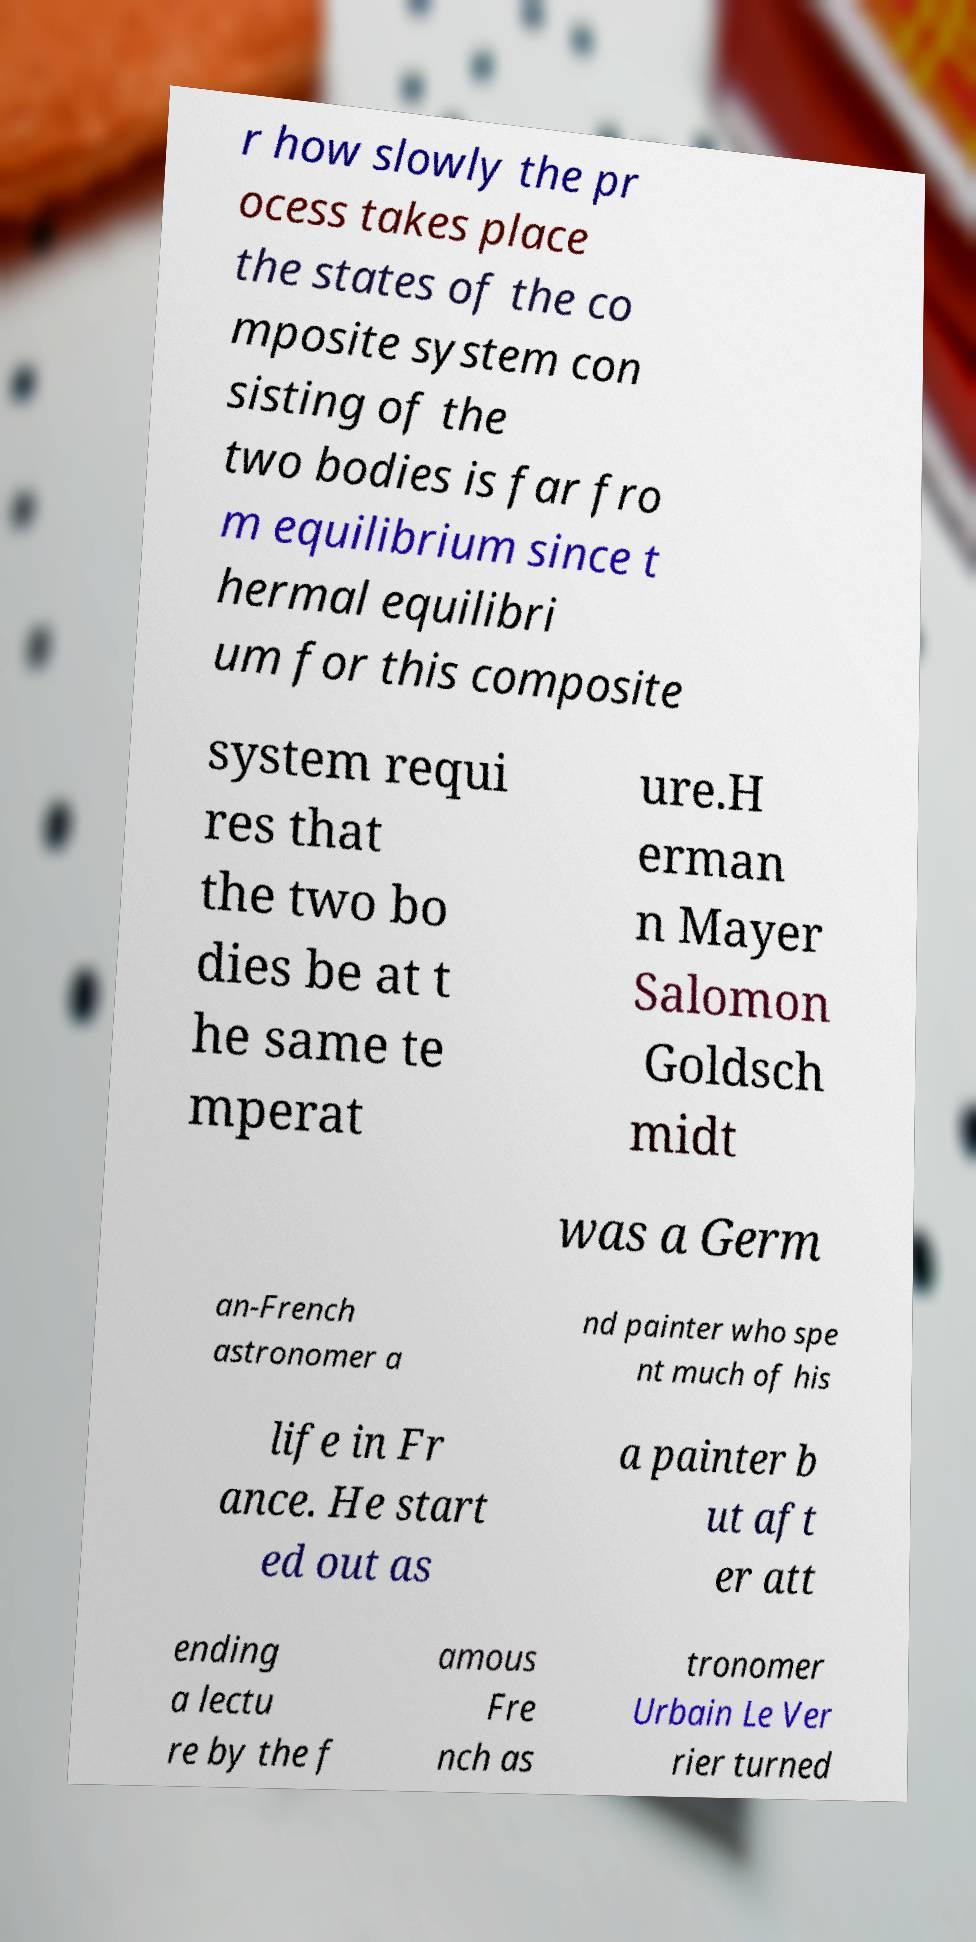Can you read and provide the text displayed in the image?This photo seems to have some interesting text. Can you extract and type it out for me? r how slowly the pr ocess takes place the states of the co mposite system con sisting of the two bodies is far fro m equilibrium since t hermal equilibri um for this composite system requi res that the two bo dies be at t he same te mperat ure.H erman n Mayer Salomon Goldsch midt was a Germ an-French astronomer a nd painter who spe nt much of his life in Fr ance. He start ed out as a painter b ut aft er att ending a lectu re by the f amous Fre nch as tronomer Urbain Le Ver rier turned 